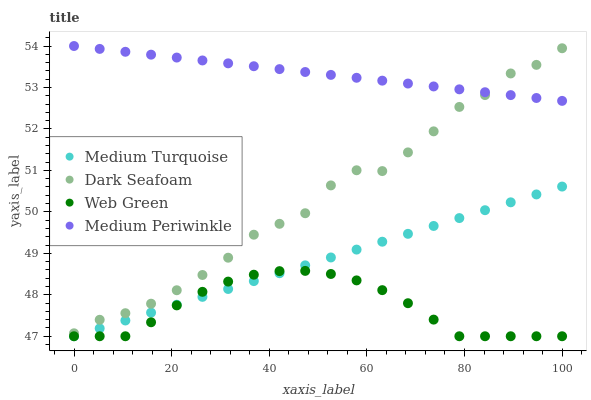Does Web Green have the minimum area under the curve?
Answer yes or no. Yes. Does Medium Periwinkle have the maximum area under the curve?
Answer yes or no. Yes. Does Medium Periwinkle have the minimum area under the curve?
Answer yes or no. No. Does Web Green have the maximum area under the curve?
Answer yes or no. No. Is Medium Periwinkle the smoothest?
Answer yes or no. Yes. Is Dark Seafoam the roughest?
Answer yes or no. Yes. Is Web Green the smoothest?
Answer yes or no. No. Is Web Green the roughest?
Answer yes or no. No. Does Web Green have the lowest value?
Answer yes or no. Yes. Does Medium Periwinkle have the lowest value?
Answer yes or no. No. Does Medium Periwinkle have the highest value?
Answer yes or no. Yes. Does Web Green have the highest value?
Answer yes or no. No. Is Web Green less than Dark Seafoam?
Answer yes or no. Yes. Is Dark Seafoam greater than Medium Turquoise?
Answer yes or no. Yes. Does Web Green intersect Medium Turquoise?
Answer yes or no. Yes. Is Web Green less than Medium Turquoise?
Answer yes or no. No. Is Web Green greater than Medium Turquoise?
Answer yes or no. No. Does Web Green intersect Dark Seafoam?
Answer yes or no. No. 